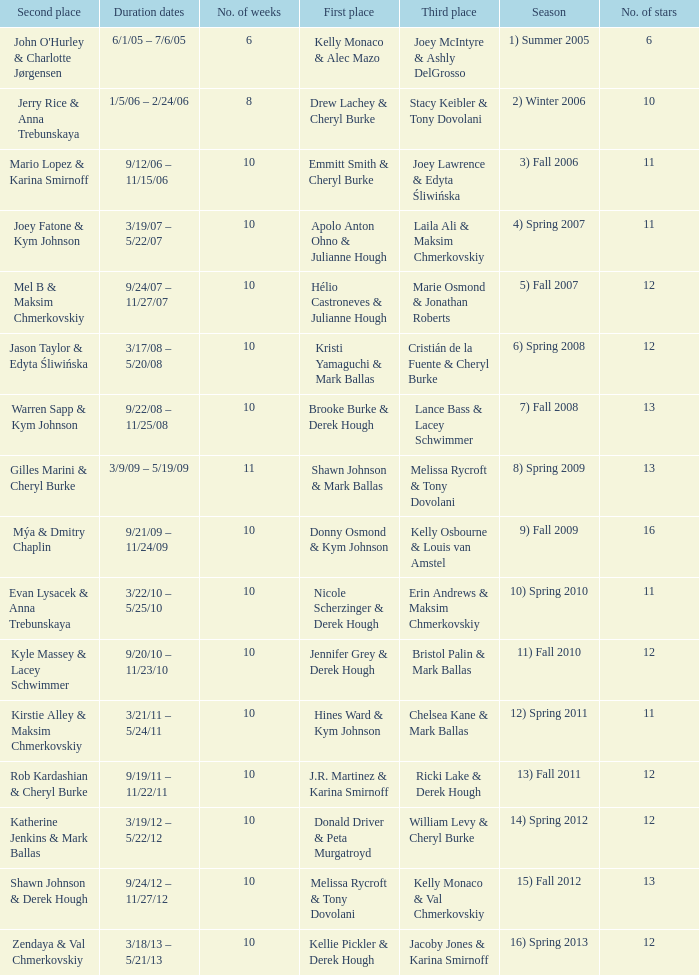Who took first place in week 6? 1.0. 